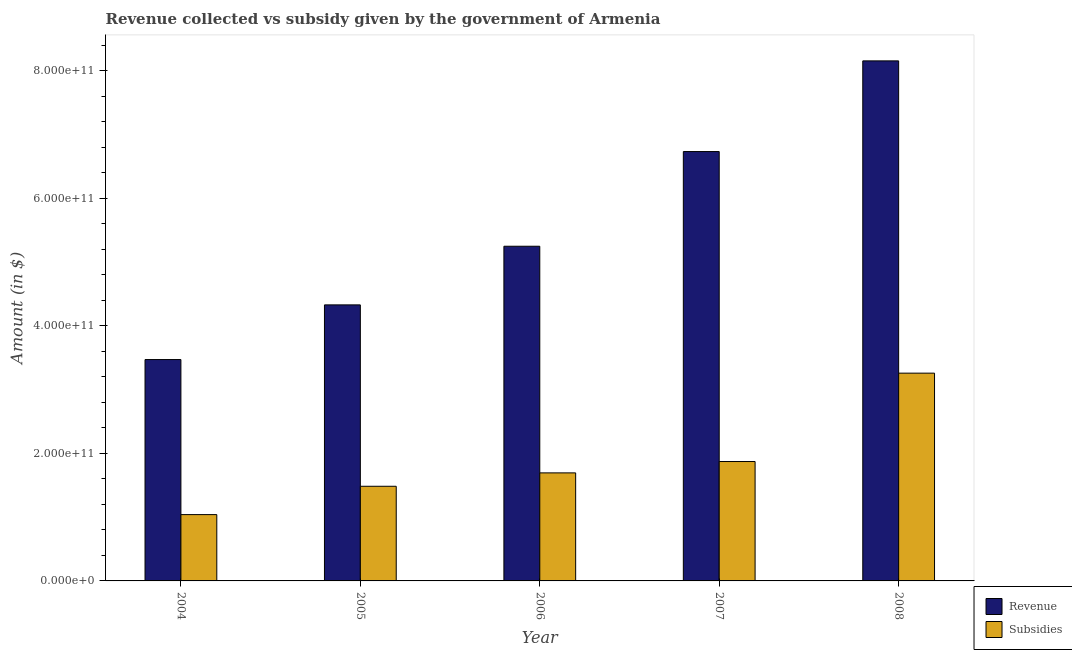How many different coloured bars are there?
Your answer should be very brief. 2. How many groups of bars are there?
Provide a succinct answer. 5. How many bars are there on the 1st tick from the left?
Make the answer very short. 2. What is the label of the 2nd group of bars from the left?
Your answer should be compact. 2005. In how many cases, is the number of bars for a given year not equal to the number of legend labels?
Provide a short and direct response. 0. What is the amount of revenue collected in 2008?
Give a very brief answer. 8.16e+11. Across all years, what is the maximum amount of subsidies given?
Offer a very short reply. 3.26e+11. Across all years, what is the minimum amount of revenue collected?
Make the answer very short. 3.47e+11. What is the total amount of revenue collected in the graph?
Provide a short and direct response. 2.79e+12. What is the difference between the amount of subsidies given in 2006 and that in 2008?
Your answer should be compact. -1.56e+11. What is the difference between the amount of subsidies given in 2008 and the amount of revenue collected in 2007?
Your answer should be compact. 1.39e+11. What is the average amount of subsidies given per year?
Offer a terse response. 1.87e+11. In the year 2005, what is the difference between the amount of subsidies given and amount of revenue collected?
Your answer should be very brief. 0. In how many years, is the amount of revenue collected greater than 160000000000 $?
Offer a terse response. 5. What is the ratio of the amount of revenue collected in 2005 to that in 2007?
Provide a succinct answer. 0.64. What is the difference between the highest and the second highest amount of revenue collected?
Keep it short and to the point. 1.42e+11. What is the difference between the highest and the lowest amount of subsidies given?
Your answer should be compact. 2.22e+11. In how many years, is the amount of revenue collected greater than the average amount of revenue collected taken over all years?
Offer a very short reply. 2. What does the 2nd bar from the left in 2005 represents?
Ensure brevity in your answer.  Subsidies. What does the 1st bar from the right in 2004 represents?
Make the answer very short. Subsidies. How many bars are there?
Keep it short and to the point. 10. Are all the bars in the graph horizontal?
Keep it short and to the point. No. How many years are there in the graph?
Provide a succinct answer. 5. What is the difference between two consecutive major ticks on the Y-axis?
Make the answer very short. 2.00e+11. Are the values on the major ticks of Y-axis written in scientific E-notation?
Offer a very short reply. Yes. Does the graph contain any zero values?
Give a very brief answer. No. Where does the legend appear in the graph?
Your response must be concise. Bottom right. What is the title of the graph?
Keep it short and to the point. Revenue collected vs subsidy given by the government of Armenia. What is the label or title of the X-axis?
Your answer should be very brief. Year. What is the label or title of the Y-axis?
Your response must be concise. Amount (in $). What is the Amount (in $) of Revenue in 2004?
Give a very brief answer. 3.47e+11. What is the Amount (in $) in Subsidies in 2004?
Make the answer very short. 1.04e+11. What is the Amount (in $) of Revenue in 2005?
Provide a succinct answer. 4.33e+11. What is the Amount (in $) of Subsidies in 2005?
Your answer should be very brief. 1.48e+11. What is the Amount (in $) of Revenue in 2006?
Provide a short and direct response. 5.25e+11. What is the Amount (in $) in Subsidies in 2006?
Keep it short and to the point. 1.69e+11. What is the Amount (in $) in Revenue in 2007?
Offer a very short reply. 6.73e+11. What is the Amount (in $) of Subsidies in 2007?
Your answer should be compact. 1.87e+11. What is the Amount (in $) of Revenue in 2008?
Your answer should be very brief. 8.16e+11. What is the Amount (in $) in Subsidies in 2008?
Provide a short and direct response. 3.26e+11. Across all years, what is the maximum Amount (in $) of Revenue?
Give a very brief answer. 8.16e+11. Across all years, what is the maximum Amount (in $) in Subsidies?
Your answer should be compact. 3.26e+11. Across all years, what is the minimum Amount (in $) of Revenue?
Your response must be concise. 3.47e+11. Across all years, what is the minimum Amount (in $) of Subsidies?
Provide a succinct answer. 1.04e+11. What is the total Amount (in $) of Revenue in the graph?
Provide a succinct answer. 2.79e+12. What is the total Amount (in $) in Subsidies in the graph?
Offer a terse response. 9.35e+11. What is the difference between the Amount (in $) in Revenue in 2004 and that in 2005?
Make the answer very short. -8.58e+1. What is the difference between the Amount (in $) of Subsidies in 2004 and that in 2005?
Give a very brief answer. -4.45e+1. What is the difference between the Amount (in $) of Revenue in 2004 and that in 2006?
Give a very brief answer. -1.78e+11. What is the difference between the Amount (in $) of Subsidies in 2004 and that in 2006?
Offer a very short reply. -6.54e+1. What is the difference between the Amount (in $) in Revenue in 2004 and that in 2007?
Your answer should be very brief. -3.26e+11. What is the difference between the Amount (in $) of Subsidies in 2004 and that in 2007?
Provide a succinct answer. -8.33e+1. What is the difference between the Amount (in $) in Revenue in 2004 and that in 2008?
Offer a terse response. -4.68e+11. What is the difference between the Amount (in $) of Subsidies in 2004 and that in 2008?
Your answer should be compact. -2.22e+11. What is the difference between the Amount (in $) in Revenue in 2005 and that in 2006?
Offer a very short reply. -9.20e+1. What is the difference between the Amount (in $) of Subsidies in 2005 and that in 2006?
Your answer should be very brief. -2.10e+1. What is the difference between the Amount (in $) of Revenue in 2005 and that in 2007?
Offer a very short reply. -2.40e+11. What is the difference between the Amount (in $) in Subsidies in 2005 and that in 2007?
Your answer should be very brief. -3.88e+1. What is the difference between the Amount (in $) in Revenue in 2005 and that in 2008?
Keep it short and to the point. -3.83e+11. What is the difference between the Amount (in $) of Subsidies in 2005 and that in 2008?
Offer a very short reply. -1.77e+11. What is the difference between the Amount (in $) in Revenue in 2006 and that in 2007?
Keep it short and to the point. -1.49e+11. What is the difference between the Amount (in $) of Subsidies in 2006 and that in 2007?
Your response must be concise. -1.78e+1. What is the difference between the Amount (in $) of Revenue in 2006 and that in 2008?
Keep it short and to the point. -2.91e+11. What is the difference between the Amount (in $) of Subsidies in 2006 and that in 2008?
Keep it short and to the point. -1.56e+11. What is the difference between the Amount (in $) in Revenue in 2007 and that in 2008?
Your answer should be very brief. -1.42e+11. What is the difference between the Amount (in $) in Subsidies in 2007 and that in 2008?
Ensure brevity in your answer.  -1.39e+11. What is the difference between the Amount (in $) of Revenue in 2004 and the Amount (in $) of Subsidies in 2005?
Provide a succinct answer. 1.99e+11. What is the difference between the Amount (in $) in Revenue in 2004 and the Amount (in $) in Subsidies in 2006?
Your response must be concise. 1.78e+11. What is the difference between the Amount (in $) of Revenue in 2004 and the Amount (in $) of Subsidies in 2007?
Your answer should be compact. 1.60e+11. What is the difference between the Amount (in $) in Revenue in 2004 and the Amount (in $) in Subsidies in 2008?
Provide a succinct answer. 2.13e+1. What is the difference between the Amount (in $) in Revenue in 2005 and the Amount (in $) in Subsidies in 2006?
Ensure brevity in your answer.  2.64e+11. What is the difference between the Amount (in $) in Revenue in 2005 and the Amount (in $) in Subsidies in 2007?
Give a very brief answer. 2.46e+11. What is the difference between the Amount (in $) in Revenue in 2005 and the Amount (in $) in Subsidies in 2008?
Provide a short and direct response. 1.07e+11. What is the difference between the Amount (in $) in Revenue in 2006 and the Amount (in $) in Subsidies in 2007?
Your answer should be compact. 3.38e+11. What is the difference between the Amount (in $) of Revenue in 2006 and the Amount (in $) of Subsidies in 2008?
Offer a very short reply. 1.99e+11. What is the difference between the Amount (in $) of Revenue in 2007 and the Amount (in $) of Subsidies in 2008?
Your response must be concise. 3.48e+11. What is the average Amount (in $) of Revenue per year?
Give a very brief answer. 5.59e+11. What is the average Amount (in $) in Subsidies per year?
Offer a very short reply. 1.87e+11. In the year 2004, what is the difference between the Amount (in $) in Revenue and Amount (in $) in Subsidies?
Offer a terse response. 2.43e+11. In the year 2005, what is the difference between the Amount (in $) in Revenue and Amount (in $) in Subsidies?
Ensure brevity in your answer.  2.85e+11. In the year 2006, what is the difference between the Amount (in $) in Revenue and Amount (in $) in Subsidies?
Offer a very short reply. 3.55e+11. In the year 2007, what is the difference between the Amount (in $) of Revenue and Amount (in $) of Subsidies?
Ensure brevity in your answer.  4.86e+11. In the year 2008, what is the difference between the Amount (in $) in Revenue and Amount (in $) in Subsidies?
Keep it short and to the point. 4.90e+11. What is the ratio of the Amount (in $) of Revenue in 2004 to that in 2005?
Provide a short and direct response. 0.8. What is the ratio of the Amount (in $) in Subsidies in 2004 to that in 2005?
Your answer should be compact. 0.7. What is the ratio of the Amount (in $) of Revenue in 2004 to that in 2006?
Ensure brevity in your answer.  0.66. What is the ratio of the Amount (in $) in Subsidies in 2004 to that in 2006?
Offer a terse response. 0.61. What is the ratio of the Amount (in $) in Revenue in 2004 to that in 2007?
Provide a succinct answer. 0.52. What is the ratio of the Amount (in $) in Subsidies in 2004 to that in 2007?
Provide a short and direct response. 0.56. What is the ratio of the Amount (in $) of Revenue in 2004 to that in 2008?
Give a very brief answer. 0.43. What is the ratio of the Amount (in $) in Subsidies in 2004 to that in 2008?
Your answer should be compact. 0.32. What is the ratio of the Amount (in $) in Revenue in 2005 to that in 2006?
Your response must be concise. 0.82. What is the ratio of the Amount (in $) of Subsidies in 2005 to that in 2006?
Offer a very short reply. 0.88. What is the ratio of the Amount (in $) in Revenue in 2005 to that in 2007?
Your response must be concise. 0.64. What is the ratio of the Amount (in $) of Subsidies in 2005 to that in 2007?
Keep it short and to the point. 0.79. What is the ratio of the Amount (in $) of Revenue in 2005 to that in 2008?
Make the answer very short. 0.53. What is the ratio of the Amount (in $) of Subsidies in 2005 to that in 2008?
Provide a succinct answer. 0.46. What is the ratio of the Amount (in $) in Revenue in 2006 to that in 2007?
Give a very brief answer. 0.78. What is the ratio of the Amount (in $) in Subsidies in 2006 to that in 2007?
Offer a very short reply. 0.9. What is the ratio of the Amount (in $) in Revenue in 2006 to that in 2008?
Your answer should be very brief. 0.64. What is the ratio of the Amount (in $) in Subsidies in 2006 to that in 2008?
Keep it short and to the point. 0.52. What is the ratio of the Amount (in $) of Revenue in 2007 to that in 2008?
Your answer should be compact. 0.83. What is the ratio of the Amount (in $) in Subsidies in 2007 to that in 2008?
Provide a short and direct response. 0.57. What is the difference between the highest and the second highest Amount (in $) of Revenue?
Your response must be concise. 1.42e+11. What is the difference between the highest and the second highest Amount (in $) of Subsidies?
Your answer should be compact. 1.39e+11. What is the difference between the highest and the lowest Amount (in $) in Revenue?
Provide a short and direct response. 4.68e+11. What is the difference between the highest and the lowest Amount (in $) in Subsidies?
Your response must be concise. 2.22e+11. 